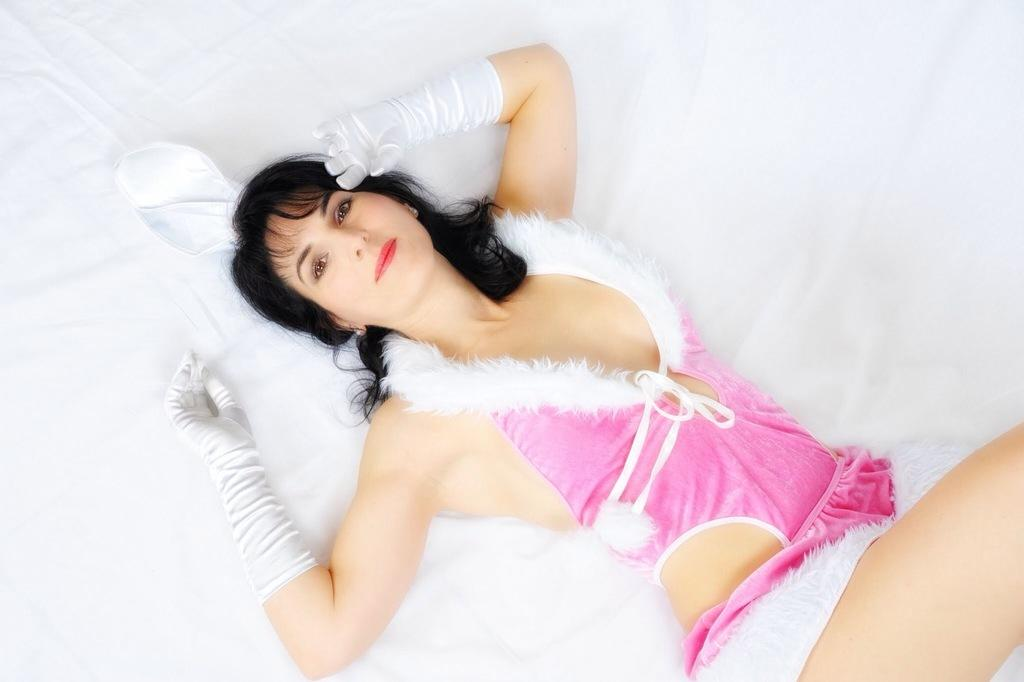Who is the main subject in the image? There is a woman in the image. What is the woman doing in the image? The woman is lying on a white cloth. What type of action is the woman performing near the lake in the image? There is no lake present in the image, and the woman is not performing any action near a lake. 